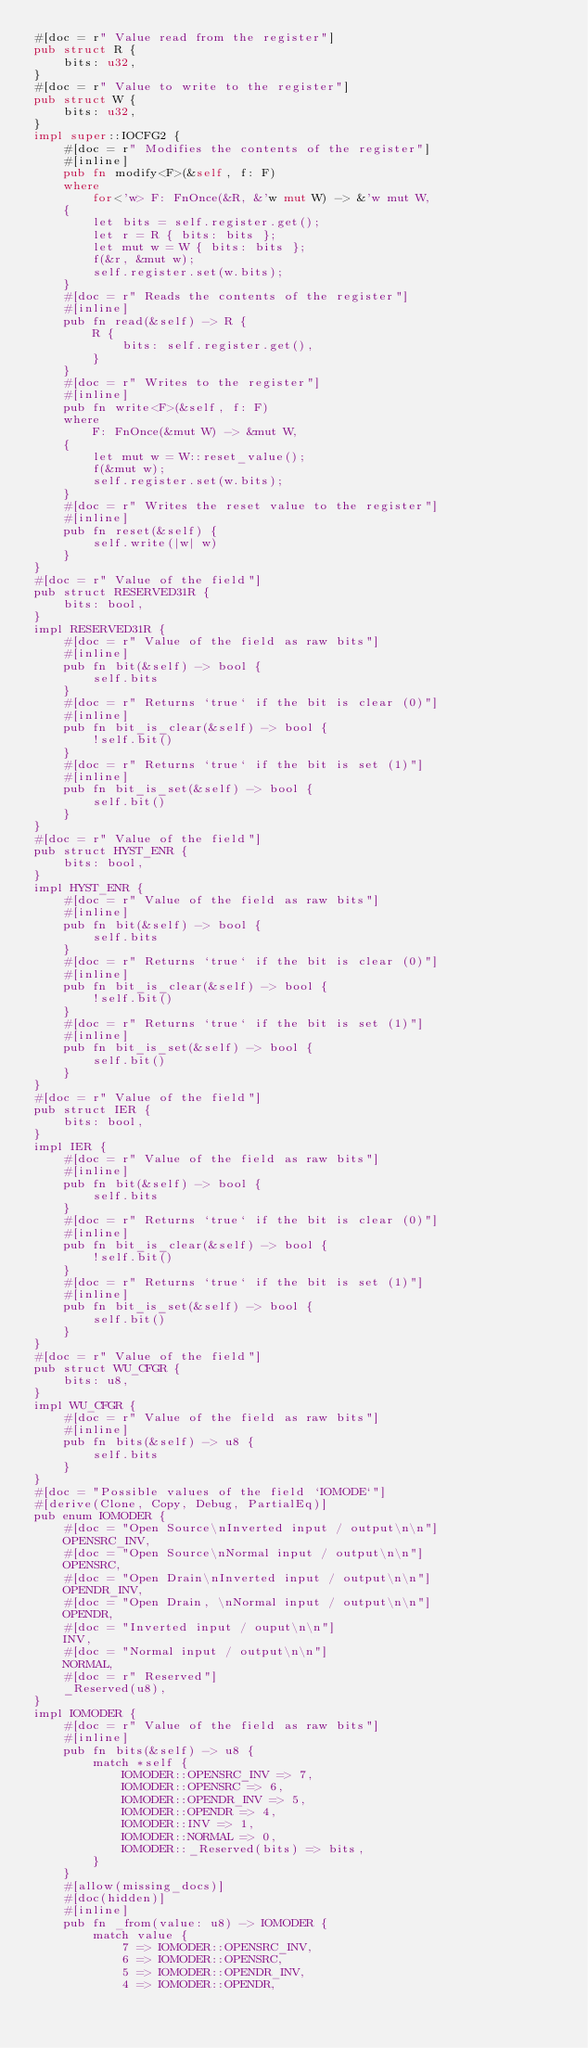<code> <loc_0><loc_0><loc_500><loc_500><_Rust_>#[doc = r" Value read from the register"]
pub struct R {
    bits: u32,
}
#[doc = r" Value to write to the register"]
pub struct W {
    bits: u32,
}
impl super::IOCFG2 {
    #[doc = r" Modifies the contents of the register"]
    #[inline]
    pub fn modify<F>(&self, f: F)
    where
        for<'w> F: FnOnce(&R, &'w mut W) -> &'w mut W,
    {
        let bits = self.register.get();
        let r = R { bits: bits };
        let mut w = W { bits: bits };
        f(&r, &mut w);
        self.register.set(w.bits);
    }
    #[doc = r" Reads the contents of the register"]
    #[inline]
    pub fn read(&self) -> R {
        R {
            bits: self.register.get(),
        }
    }
    #[doc = r" Writes to the register"]
    #[inline]
    pub fn write<F>(&self, f: F)
    where
        F: FnOnce(&mut W) -> &mut W,
    {
        let mut w = W::reset_value();
        f(&mut w);
        self.register.set(w.bits);
    }
    #[doc = r" Writes the reset value to the register"]
    #[inline]
    pub fn reset(&self) {
        self.write(|w| w)
    }
}
#[doc = r" Value of the field"]
pub struct RESERVED31R {
    bits: bool,
}
impl RESERVED31R {
    #[doc = r" Value of the field as raw bits"]
    #[inline]
    pub fn bit(&self) -> bool {
        self.bits
    }
    #[doc = r" Returns `true` if the bit is clear (0)"]
    #[inline]
    pub fn bit_is_clear(&self) -> bool {
        !self.bit()
    }
    #[doc = r" Returns `true` if the bit is set (1)"]
    #[inline]
    pub fn bit_is_set(&self) -> bool {
        self.bit()
    }
}
#[doc = r" Value of the field"]
pub struct HYST_ENR {
    bits: bool,
}
impl HYST_ENR {
    #[doc = r" Value of the field as raw bits"]
    #[inline]
    pub fn bit(&self) -> bool {
        self.bits
    }
    #[doc = r" Returns `true` if the bit is clear (0)"]
    #[inline]
    pub fn bit_is_clear(&self) -> bool {
        !self.bit()
    }
    #[doc = r" Returns `true` if the bit is set (1)"]
    #[inline]
    pub fn bit_is_set(&self) -> bool {
        self.bit()
    }
}
#[doc = r" Value of the field"]
pub struct IER {
    bits: bool,
}
impl IER {
    #[doc = r" Value of the field as raw bits"]
    #[inline]
    pub fn bit(&self) -> bool {
        self.bits
    }
    #[doc = r" Returns `true` if the bit is clear (0)"]
    #[inline]
    pub fn bit_is_clear(&self) -> bool {
        !self.bit()
    }
    #[doc = r" Returns `true` if the bit is set (1)"]
    #[inline]
    pub fn bit_is_set(&self) -> bool {
        self.bit()
    }
}
#[doc = r" Value of the field"]
pub struct WU_CFGR {
    bits: u8,
}
impl WU_CFGR {
    #[doc = r" Value of the field as raw bits"]
    #[inline]
    pub fn bits(&self) -> u8 {
        self.bits
    }
}
#[doc = "Possible values of the field `IOMODE`"]
#[derive(Clone, Copy, Debug, PartialEq)]
pub enum IOMODER {
    #[doc = "Open Source\nInverted input / output\n\n"]
    OPENSRC_INV,
    #[doc = "Open Source\nNormal input / output\n\n"]
    OPENSRC,
    #[doc = "Open Drain\nInverted input / output\n\n"]
    OPENDR_INV,
    #[doc = "Open Drain, \nNormal input / output\n\n"]
    OPENDR,
    #[doc = "Inverted input / ouput\n\n"]
    INV,
    #[doc = "Normal input / output\n\n"]
    NORMAL,
    #[doc = r" Reserved"]
    _Reserved(u8),
}
impl IOMODER {
    #[doc = r" Value of the field as raw bits"]
    #[inline]
    pub fn bits(&self) -> u8 {
        match *self {
            IOMODER::OPENSRC_INV => 7,
            IOMODER::OPENSRC => 6,
            IOMODER::OPENDR_INV => 5,
            IOMODER::OPENDR => 4,
            IOMODER::INV => 1,
            IOMODER::NORMAL => 0,
            IOMODER::_Reserved(bits) => bits,
        }
    }
    #[allow(missing_docs)]
    #[doc(hidden)]
    #[inline]
    pub fn _from(value: u8) -> IOMODER {
        match value {
            7 => IOMODER::OPENSRC_INV,
            6 => IOMODER::OPENSRC,
            5 => IOMODER::OPENDR_INV,
            4 => IOMODER::OPENDR,</code> 